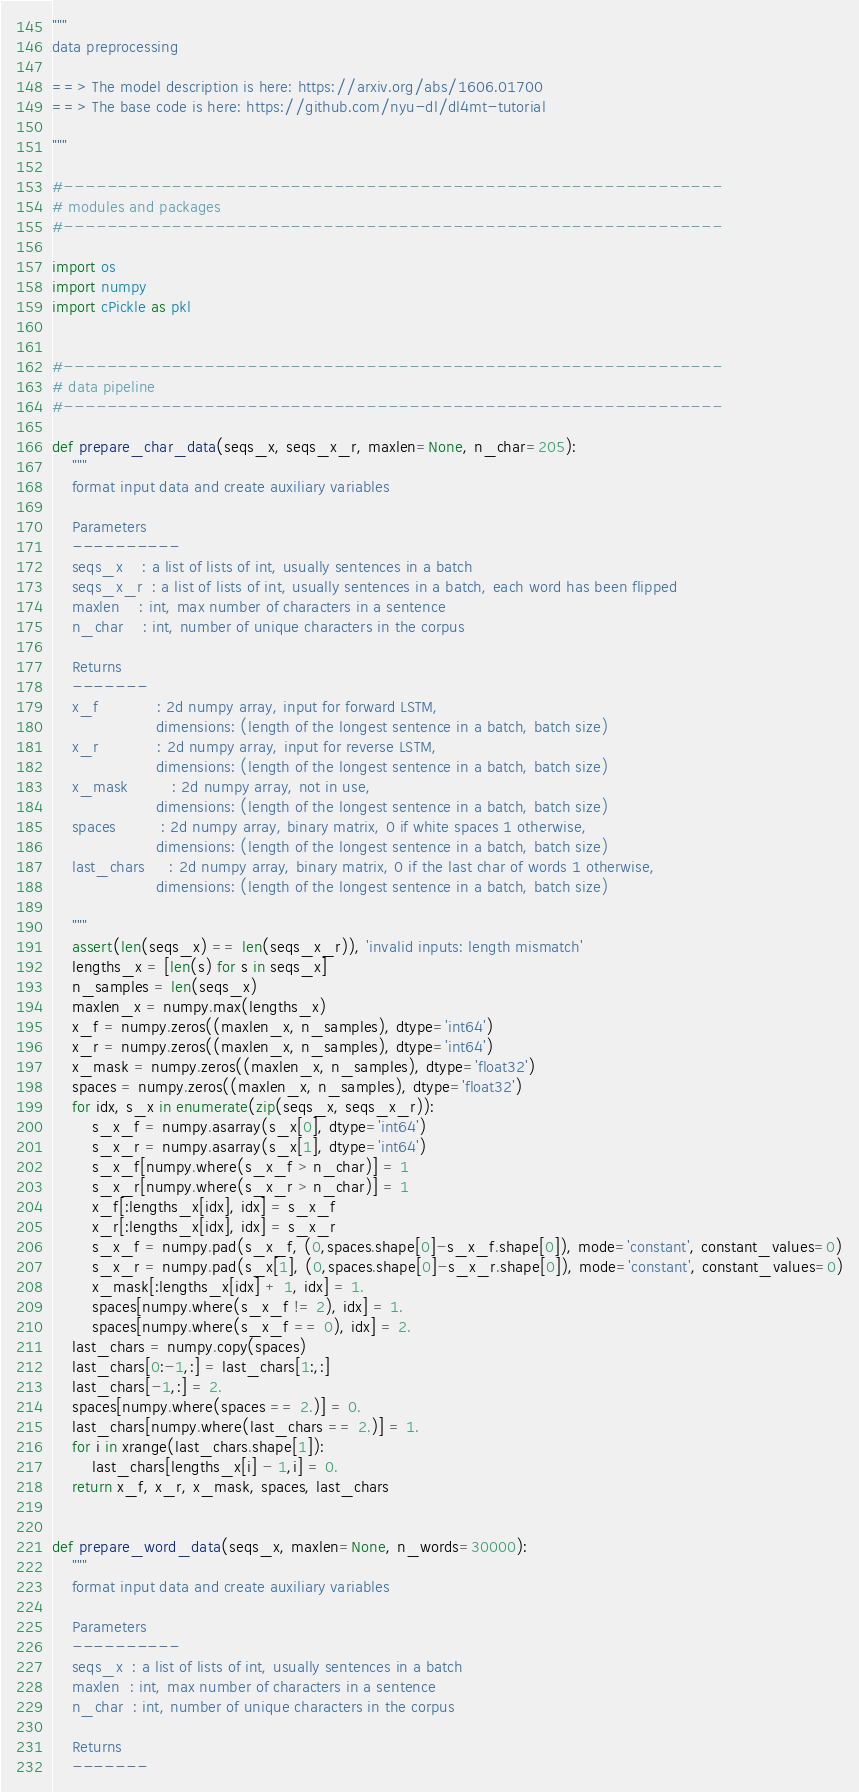Convert code to text. <code><loc_0><loc_0><loc_500><loc_500><_Python_>"""
data preprocessing

==> The model description is here: https://arxiv.org/abs/1606.01700
==> The base code is here: https://github.com/nyu-dl/dl4mt-tutorial

"""

#-------------------------------------------------------------
# modules and packages
#-------------------------------------------------------------

import os
import numpy
import cPickle as pkl


#-------------------------------------------------------------
# data pipeline
#-------------------------------------------------------------

def prepare_char_data(seqs_x, seqs_x_r, maxlen=None, n_char=205):
    """
    format input data and create auxiliary variables

    Parameters
    ----------
    seqs_x    : a list of lists of int, usually sentences in a batch
    seqs_x_r  : a list of lists of int, usually sentences in a batch, each word has been flipped
    maxlen    : int, max number of characters in a sentence
    n_char    : int, number of unique characters in the corpus 

    Returns
    -------
    x_f            : 2d numpy array, input for forward LSTM,
                     dimensions: (length of the longest sentence in a batch, batch size)
    x_r            : 2d numpy array, input for reverse LSTM,
                     dimensions: (length of the longest sentence in a batch, batch size)
    x_mask         : 2d numpy array, not in use,
                     dimensions: (length of the longest sentence in a batch, batch size)
    spaces         : 2d numpy array, binary matrix, 0 if white spaces 1 otherwise,
                     dimensions: (length of the longest sentence in a batch, batch size)
    last_chars     : 2d numpy array, binary matrix, 0 if the last char of words 1 otherwise,
                     dimensions: (length of the longest sentence in a batch, batch size)
 
    """
    assert(len(seqs_x) == len(seqs_x_r)), 'invalid inputs: length mismatch'
    lengths_x = [len(s) for s in seqs_x]
    n_samples = len(seqs_x)
    maxlen_x = numpy.max(lengths_x)
    x_f = numpy.zeros((maxlen_x, n_samples), dtype='int64')
    x_r = numpy.zeros((maxlen_x, n_samples), dtype='int64')
    x_mask = numpy.zeros((maxlen_x, n_samples), dtype='float32')
    spaces = numpy.zeros((maxlen_x, n_samples), dtype='float32')
    for idx, s_x in enumerate(zip(seqs_x, seqs_x_r)):
        s_x_f = numpy.asarray(s_x[0], dtype='int64')
        s_x_r = numpy.asarray(s_x[1], dtype='int64')
        s_x_f[numpy.where(s_x_f > n_char)] = 1
        s_x_r[numpy.where(s_x_r > n_char)] = 1
        x_f[:lengths_x[idx], idx] = s_x_f
        x_r[:lengths_x[idx], idx] = s_x_r
        s_x_f = numpy.pad(s_x_f, (0,spaces.shape[0]-s_x_f.shape[0]), mode='constant', constant_values=0)
        s_x_r = numpy.pad(s_x[1], (0,spaces.shape[0]-s_x_r.shape[0]), mode='constant', constant_values=0)
        x_mask[:lengths_x[idx] + 1, idx] = 1.
        spaces[numpy.where(s_x_f != 2), idx] = 1.
        spaces[numpy.where(s_x_f == 0), idx] = 2.
    last_chars = numpy.copy(spaces)
    last_chars[0:-1,:] = last_chars[1:,:]
    last_chars[-1,:] = 2.
    spaces[numpy.where(spaces == 2.)] = 0.
    last_chars[numpy.where(last_chars == 2.)] = 1.
    for i in xrange(last_chars.shape[1]):
        last_chars[lengths_x[i] - 1,i] = 0.
    return x_f, x_r, x_mask, spaces, last_chars


def prepare_word_data(seqs_x, maxlen=None, n_words=30000):
    """
    format input data and create auxiliary variables

    Parameters
    ----------
    seqs_x  : a list of lists of int, usually sentences in a batch
    maxlen  : int, max number of characters in a sentence
    n_char  : int, number of unique characters in the corpus 

    Returns
    -------</code> 